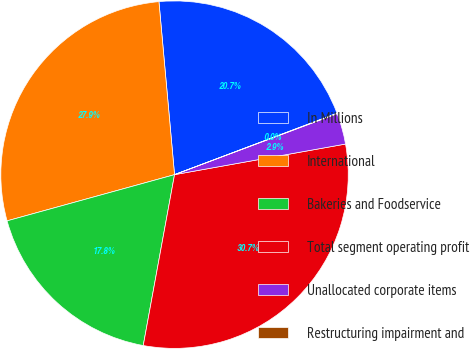Convert chart. <chart><loc_0><loc_0><loc_500><loc_500><pie_chart><fcel>In Millions<fcel>International<fcel>Bakeries and Foodservice<fcel>Total segment operating profit<fcel>Unallocated corporate items<fcel>Restructuring impairment and<nl><fcel>20.68%<fcel>27.85%<fcel>17.83%<fcel>30.7%<fcel>2.89%<fcel>0.04%<nl></chart> 